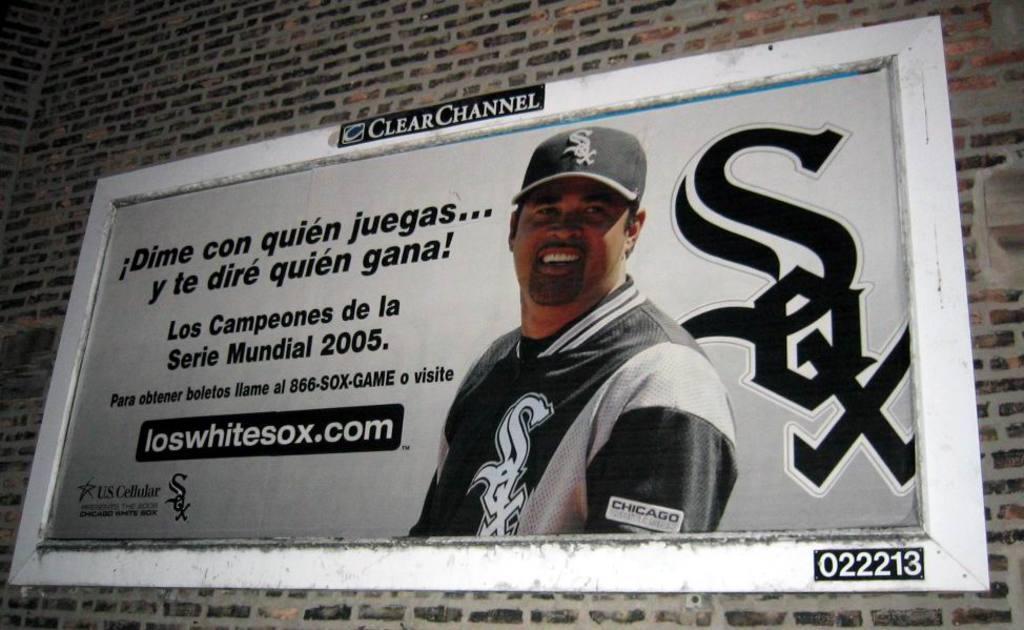Can you describe this image briefly? In the center of the image there is a brick wall. On the wall, we can see one banner. On the banner, we can see one person smiling and he is wearing a cap. And we can see some text on the banner. 